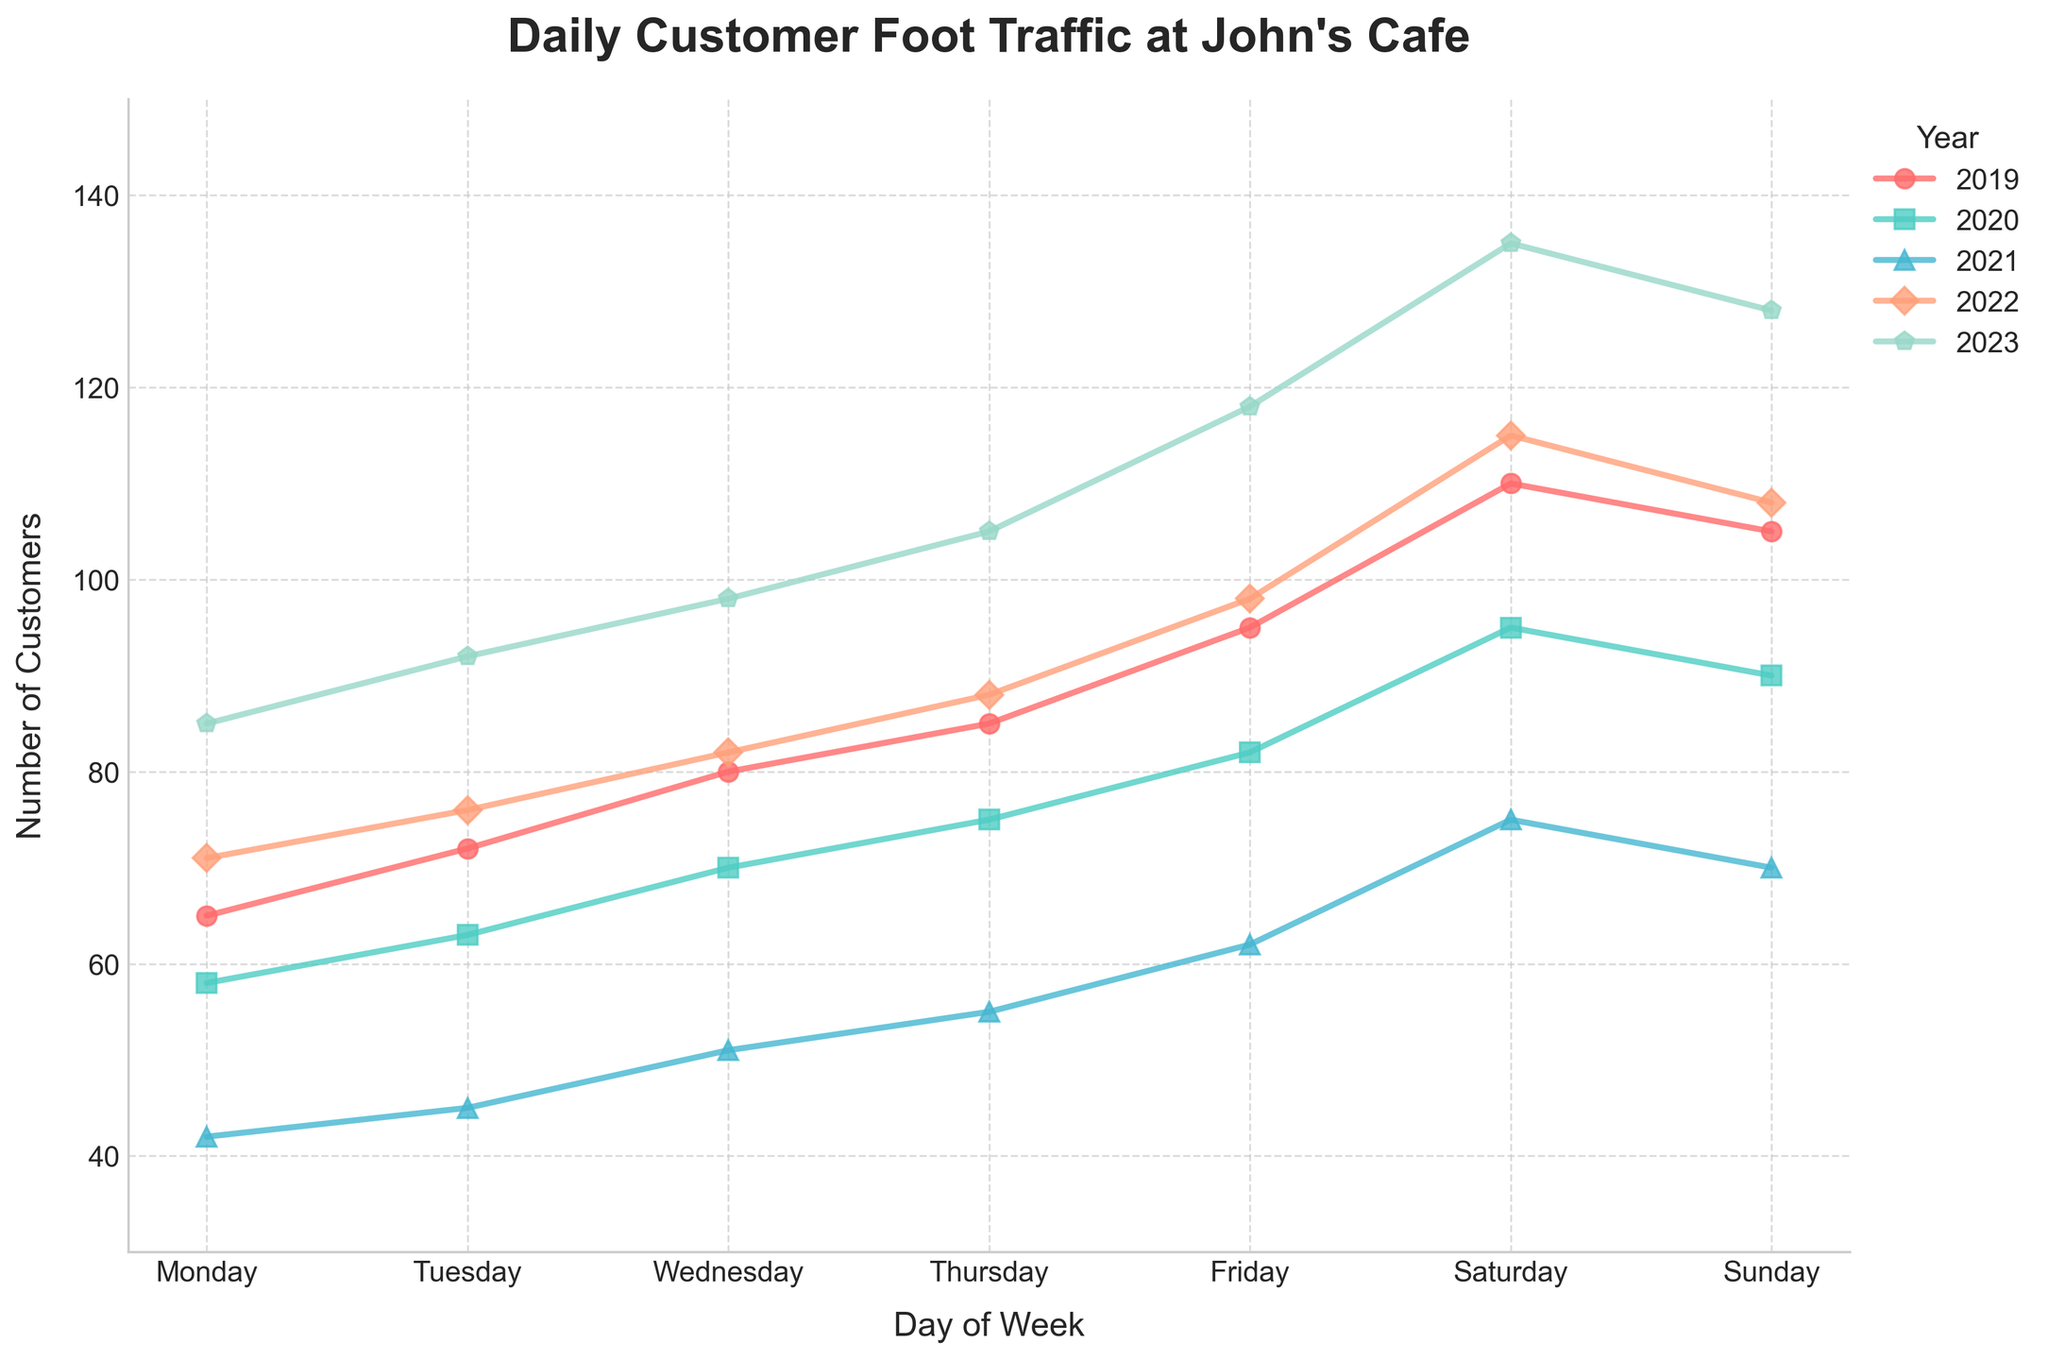Which year had the highest customer foot traffic on Friday? Observe the line representing each year, and see which line is highest on Friday. The red line (2023) is the highest on Friday.
Answer: 2023 What is the difference in customer foot traffic on Tuesdays between 2019 and 2023? Look at the vertical values for Tuesday in 2019 and 2023. 2023 has 92 customers, and 2019 has 72, so the difference is 92 - 72 = 20
Answer: 20 Which day of the week has the lowest foot traffic for 2020? Compare the lines for 2020 (in green) across all days of the week to see which day has the lowest point. The lowest point in green is Monday, with 58 customers.
Answer: Monday How has average foot traffic on Sundays changed from 2019 to 2023? Calculate the average foot traffic on Sunday for 2019 and 2023. In 2019, it is 105, and in 2023, it is 128. Hence, the average change is (128 + 105) / 2 = 116.5. Next, check the exact numbers to confirm the change is 128 - 105 = 23
Answer: 23 Which year shows the most significant increase in foot traffic from Wednesday to Thursday? To find out, observe each year's line for the jump from Wednesday to Thursday. The steepest jump occurs in the year 2023, from 98 to 105. The difference is 105 - 98 = 7.
Answer: 2023 What was the customer foot traffic on Saturdays in 2021? Locate the point of the year 2021 (in blue) on Saturday. The point shows 75 customers.
Answer: 75 By how much did the highest customer foot traffic increase from 2020 to 2023 on Saturdays? In 2020, the highest foot traffic on Saturday was 95, and in 2023, it was 135. The increase is 135 - 95 = 40.
Answer: 40 Among all days of the week, which one showed the least variation in customer foot traffic across the years? Notice the ranges for each day across the years. The day with the smallest range is Monday, with values ranging only from 42 to 85.
Answer: Monday 